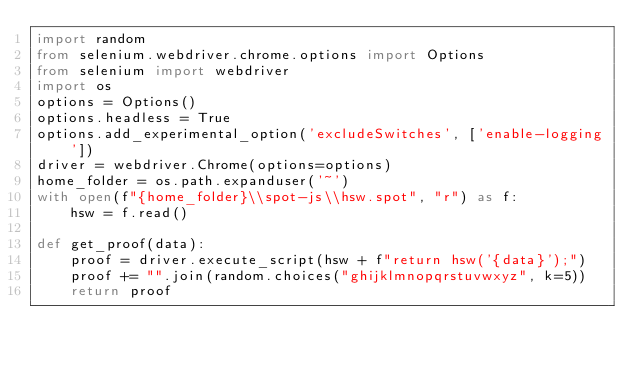<code> <loc_0><loc_0><loc_500><loc_500><_Python_>import random
from selenium.webdriver.chrome.options import Options
from selenium import webdriver
import os
options = Options()
options.headless = True
options.add_experimental_option('excludeSwitches', ['enable-logging'])
driver = webdriver.Chrome(options=options)
home_folder = os.path.expanduser('~')
with open(f"{home_folder}\\spot-js\\hsw.spot", "r") as f:
    hsw = f.read()

def get_proof(data):
    proof = driver.execute_script(hsw + f"return hsw('{data}');")
    proof += "".join(random.choices("ghijklmnopqrstuvwxyz", k=5))
    return proof
</code> 